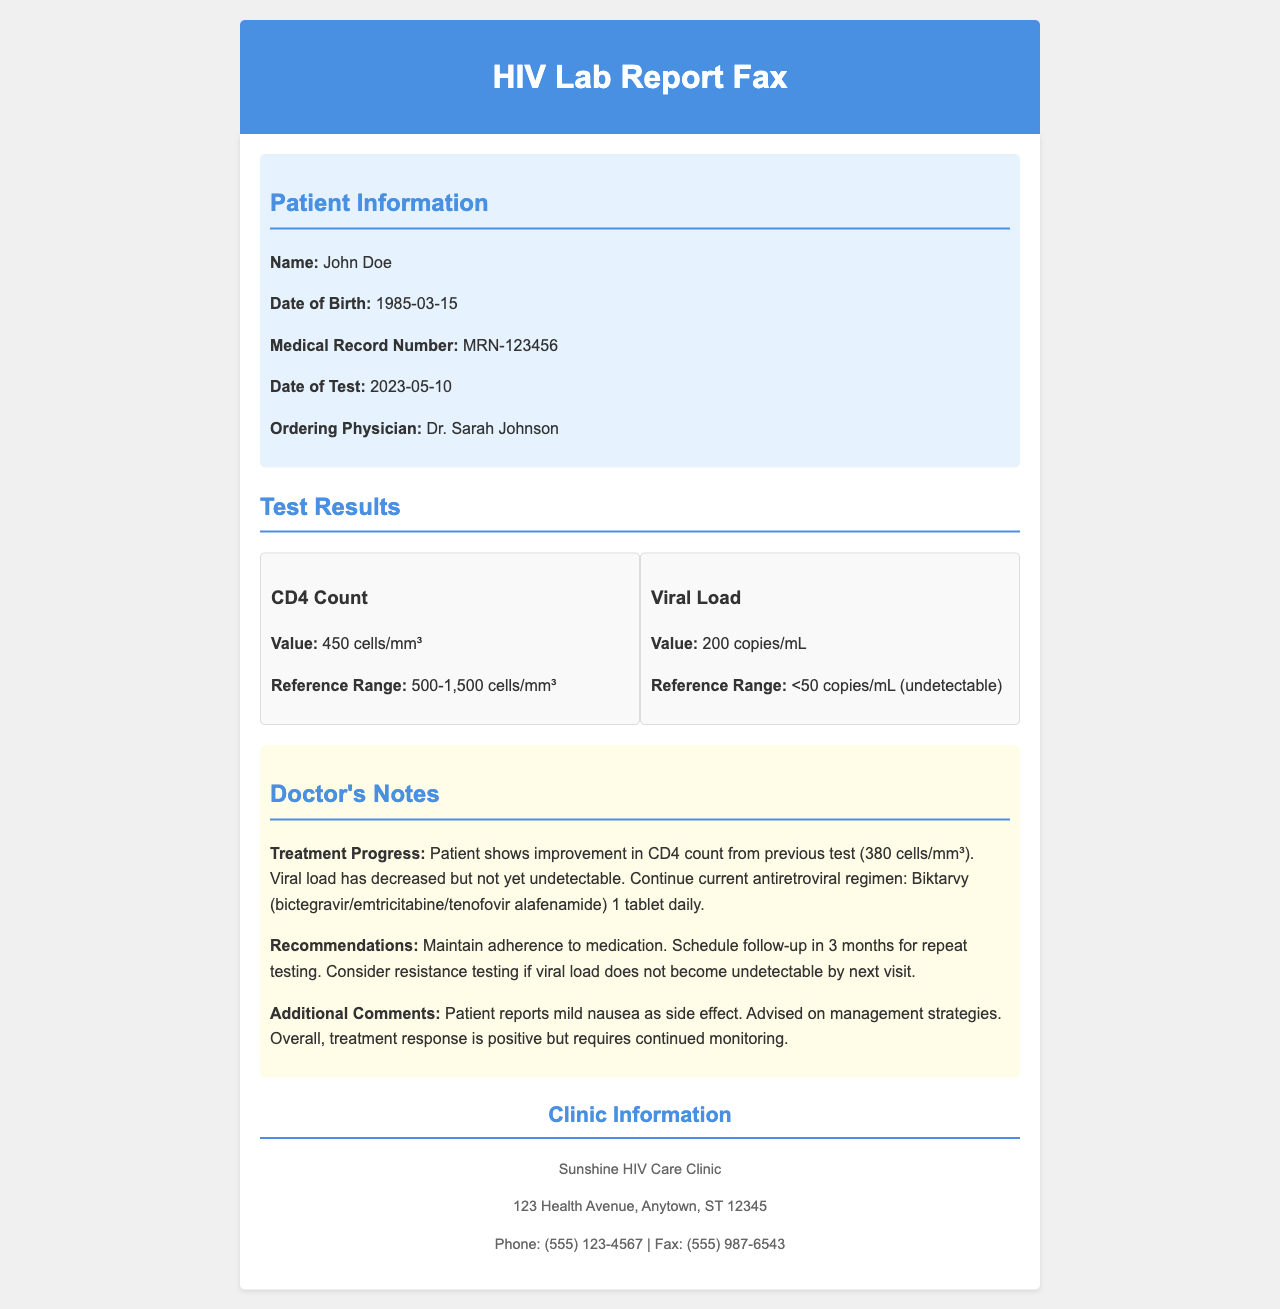What is the patient's name? The patient's name is listed in the patient information section of the document.
Answer: John Doe What is the CD4 count value? The CD4 count value is found in the test results section, specifically under CD4 Count.
Answer: 450 cells/mm³ What is the reference range for the viral load? The reference range for the viral load is stated in the results section under Viral Load.
Answer: <50 copies/mL (undetectable) Who is the ordering physician? The ordering physician is mentioned in the patient information section.
Answer: Dr. Sarah Johnson What was the CD4 count in the previous test? The previous CD4 count is mentioned in the doctor's notes regarding treatment progress.
Answer: 380 cells/mm³ What is the current antiretroviral regimen? The current antiretroviral regimen is noted in the doctor's recommendations section.
Answer: Biktarvy (bictegravir/emtricitabine/tenofovir alafenamide) 1 tablet daily When is the follow-up scheduled? The follow-up timeline is given in the doctor's notes under recommendations.
Answer: In 3 months What side effect is reported by the patient? The side effect that the patient reports is indicated in the doctor's notes.
Answer: Mild nausea What is the clinic's phone number? The clinic's contact details, including the phone number, are provided at the end of the document.
Answer: (555) 123-4567 